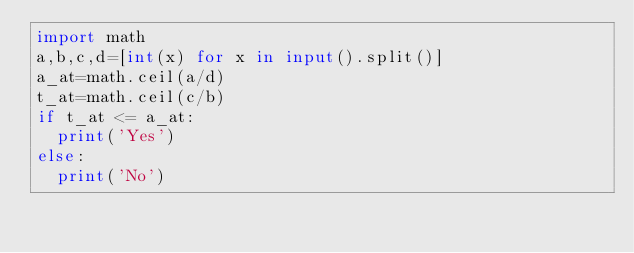<code> <loc_0><loc_0><loc_500><loc_500><_Python_>import math
a,b,c,d=[int(x) for x in input().split()]
a_at=math.ceil(a/d)
t_at=math.ceil(c/b)
if t_at <= a_at:
  print('Yes')
else:
  print('No')</code> 